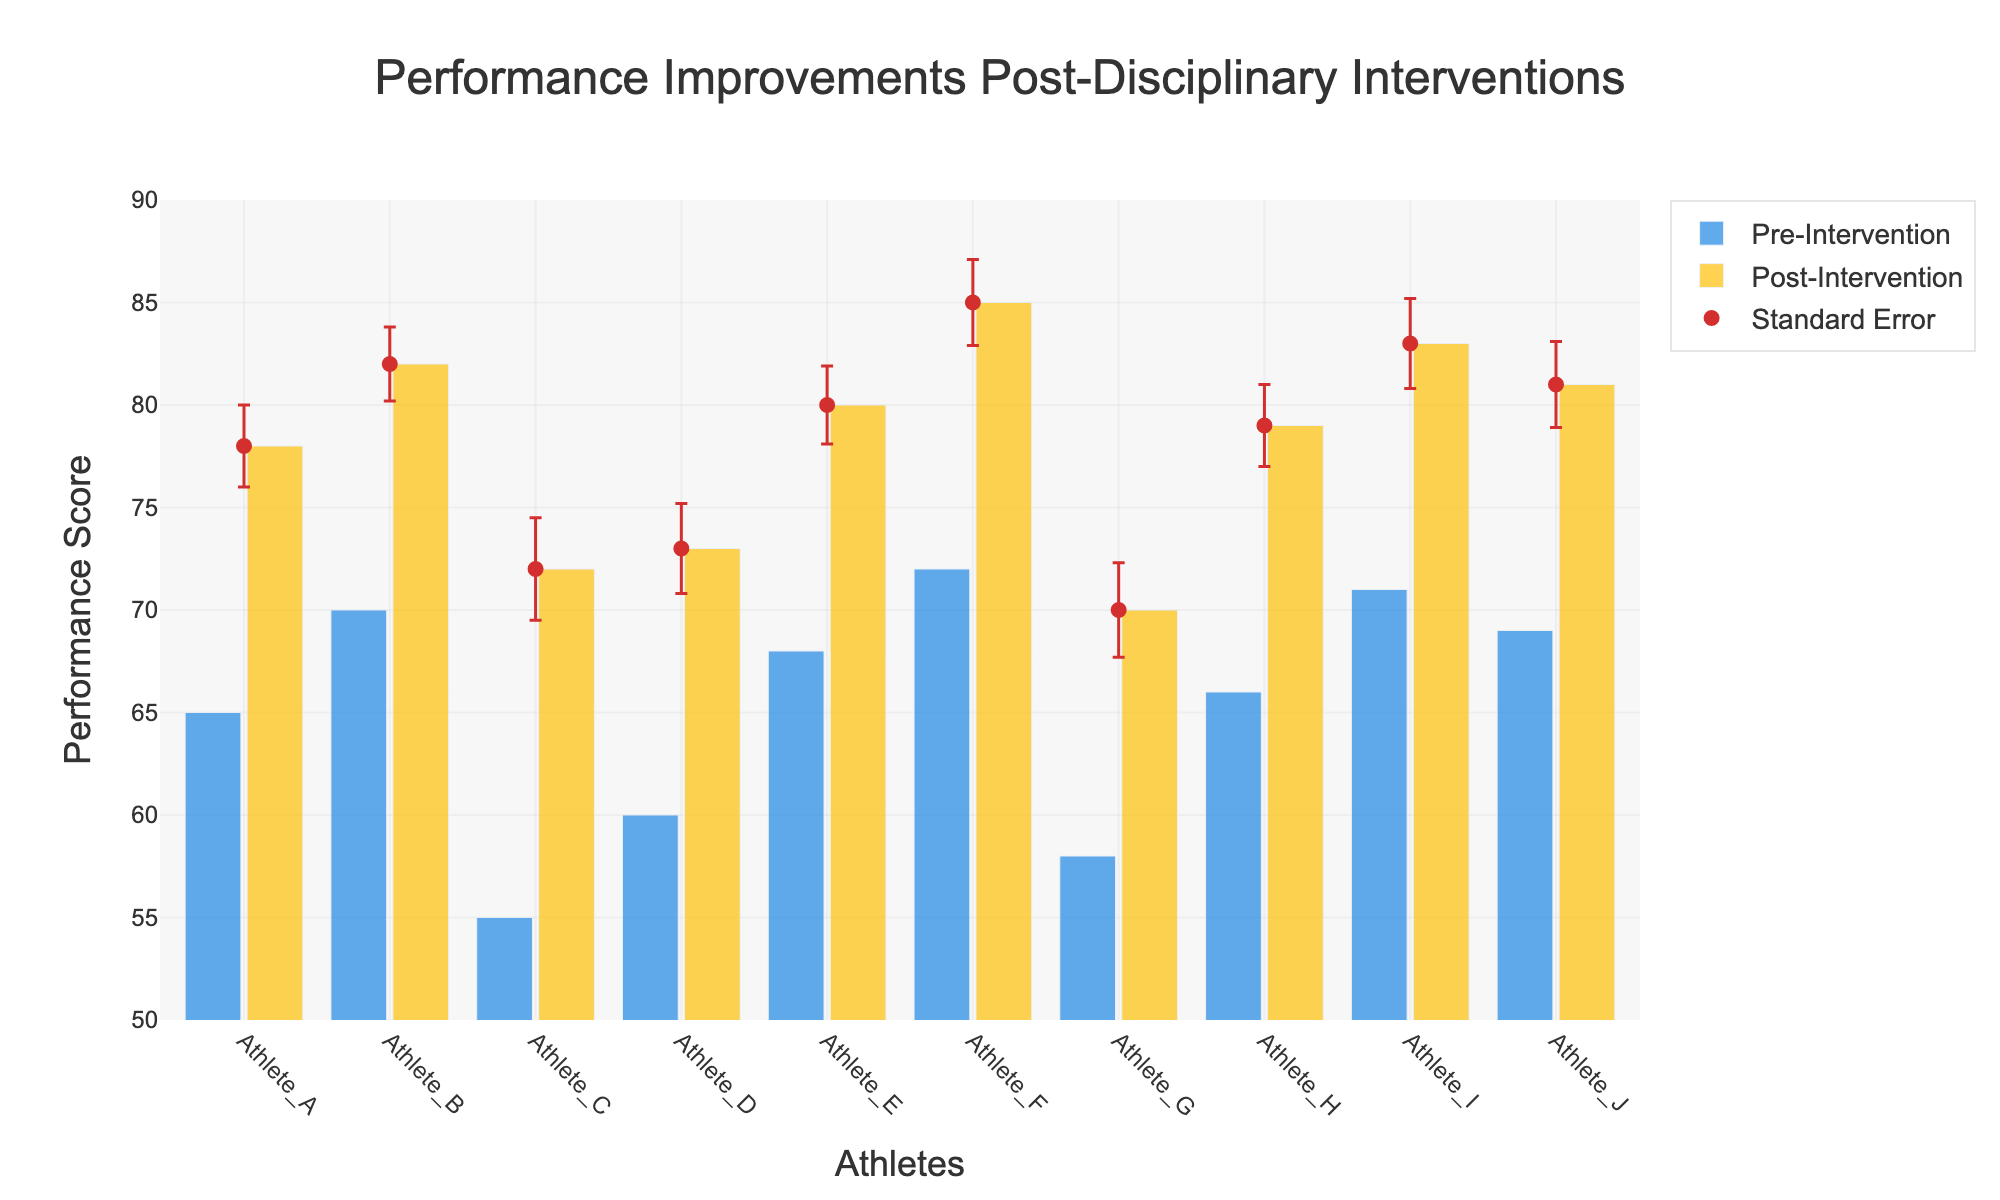How many athletes are included in the figure? To determine the number of athletes, count the unique bars (representing pre- and post-intervention) for each athlete displayed on the x-axis.
Answer: 10 What is the title of the figure? The title is displayed at the top of the figure, usually centered.
Answer: Performance Improvements Post-Disciplinary Interventions Which athlete showed the greatest improvement in performance score post-intervention? The improvement can be seen by the difference between the post-intervention performance bar and the pre-intervention performance bar. Athlete F shows the highest increase from 72 to 85.
Answer: Athlete F What's the range of the y-axis on the figure? The range of the y-axis can be determined by the axis' numerical labels, which note the minimum and maximum values it covers.
Answer: 50 to 90 Which color represents the post-intervention performance in the bars? The bar colors must be examined to differentiate between the pre- and post-intervention performances. The legend specifies this detail.
Answer: Yellow Which athlete has the highest performance score post-intervention? The highest post-intervention performance score can be identified by looking at the tallest yellow bar's y-value. Athlete F has the highest score post-intervention with 85.
Answer: Athlete F What are the standard errors for the measurements of Athlete C and Athlete E? The standard errors can be observed in the error bar heights for each athlete on the yellow bar. For Athlete C, it is 2.5; for Athlete E, it is 1.9.
Answer: 2.5, 1.9 What is the average post-intervention performance score across all athletes? Calculate the average by summing all post-intervention performances and dividing by the number of athletes. (78+82+72+73+80+85+70+79+83+81)/10 = 78.3.
Answer: 78.3 How do the standard errors impact the reliability of the performance improvements? Assess the width and visibility of the error bars and their overlap with nearby bars to understand the uncertainty and variability in measurements. Larger errors suggest less reliability. Error bars show slight variation, indicating relatively consistent improvements.
Answer: Indicate relatively consistent improvements Can we conclude that disciplinary interventions led to performance improvements for all athletes? Examine whether post-intervention performance is consistently higher than pre-intervention and account for the overlap as shown by error bars. All athletes showed higher post-intervention performance within the standard error margin, suggesting improvement.
Answer: Yes 